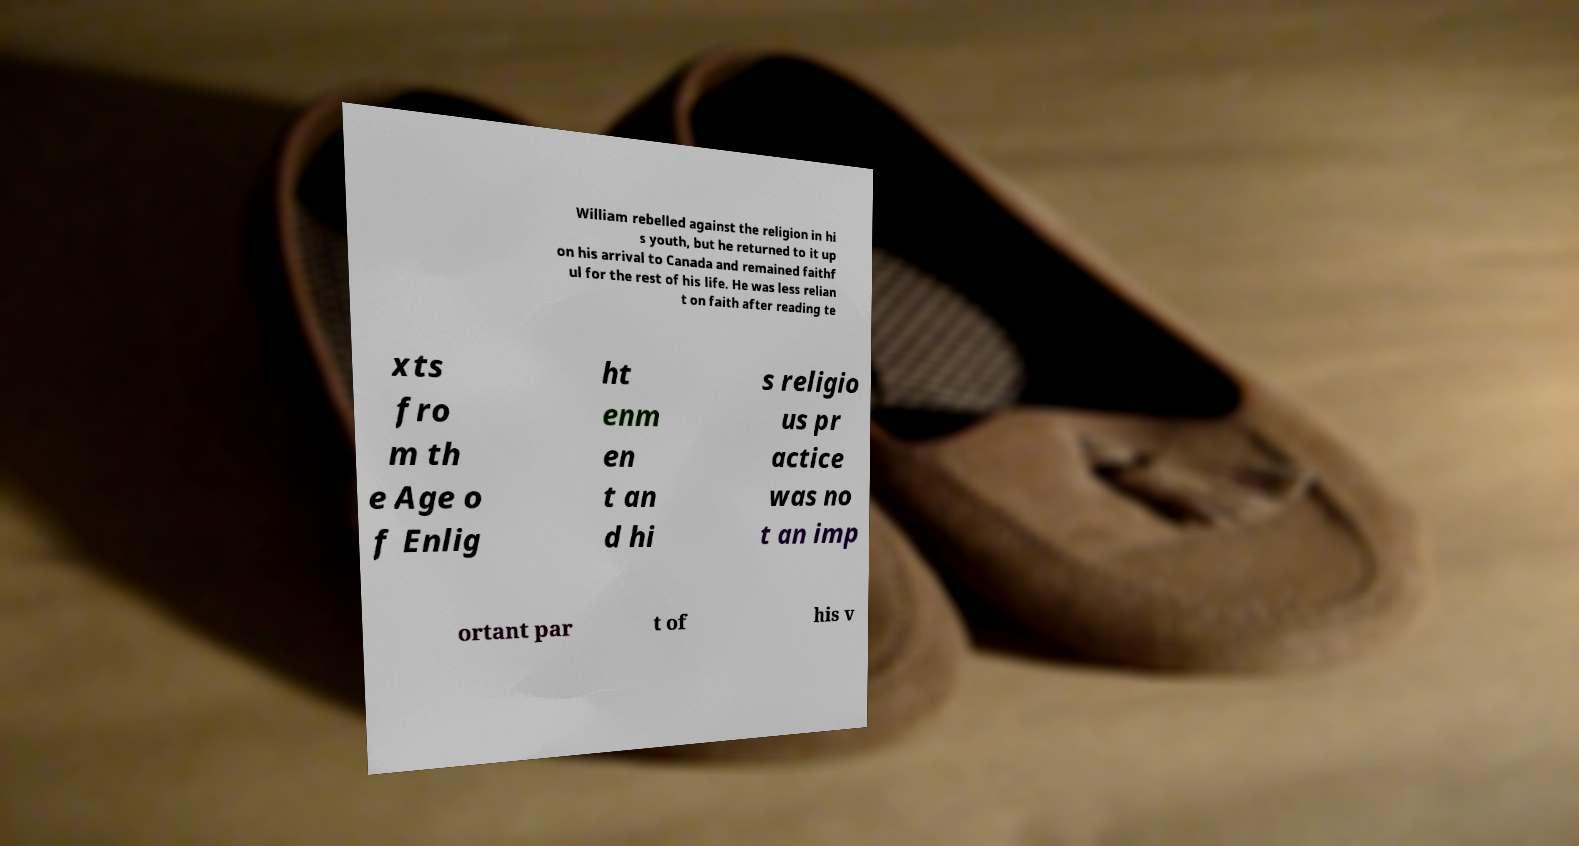Please read and relay the text visible in this image. What does it say? William rebelled against the religion in hi s youth, but he returned to it up on his arrival to Canada and remained faithf ul for the rest of his life. He was less relian t on faith after reading te xts fro m th e Age o f Enlig ht enm en t an d hi s religio us pr actice was no t an imp ortant par t of his v 